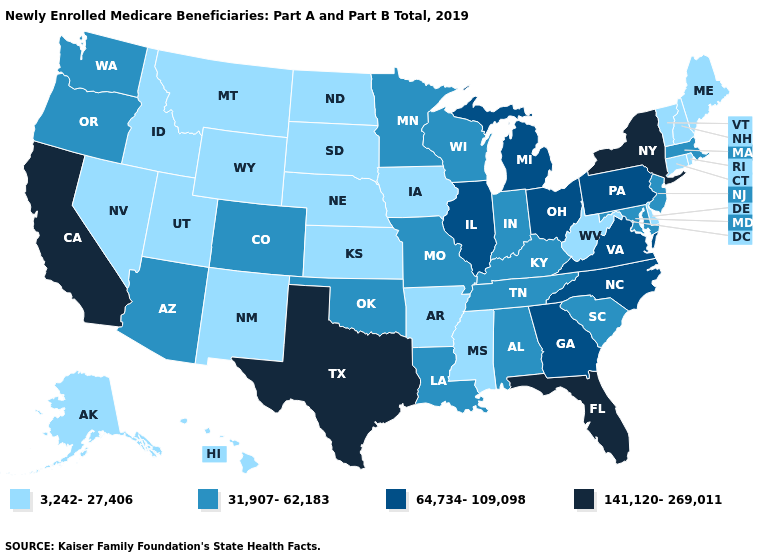What is the value of Wisconsin?
Answer briefly. 31,907-62,183. Which states have the lowest value in the Northeast?
Concise answer only. Connecticut, Maine, New Hampshire, Rhode Island, Vermont. Does Georgia have the lowest value in the USA?
Quick response, please. No. Name the states that have a value in the range 31,907-62,183?
Concise answer only. Alabama, Arizona, Colorado, Indiana, Kentucky, Louisiana, Maryland, Massachusetts, Minnesota, Missouri, New Jersey, Oklahoma, Oregon, South Carolina, Tennessee, Washington, Wisconsin. Among the states that border Virginia , which have the lowest value?
Keep it brief. West Virginia. What is the value of Colorado?
Give a very brief answer. 31,907-62,183. Does Louisiana have a higher value than Utah?
Keep it brief. Yes. What is the value of South Dakota?
Short answer required. 3,242-27,406. Does the first symbol in the legend represent the smallest category?
Be succinct. Yes. What is the value of Hawaii?
Keep it brief. 3,242-27,406. Among the states that border Mississippi , does Arkansas have the lowest value?
Be succinct. Yes. Name the states that have a value in the range 3,242-27,406?
Short answer required. Alaska, Arkansas, Connecticut, Delaware, Hawaii, Idaho, Iowa, Kansas, Maine, Mississippi, Montana, Nebraska, Nevada, New Hampshire, New Mexico, North Dakota, Rhode Island, South Dakota, Utah, Vermont, West Virginia, Wyoming. Does the map have missing data?
Give a very brief answer. No. What is the value of Indiana?
Be succinct. 31,907-62,183. Among the states that border New Hampshire , which have the lowest value?
Answer briefly. Maine, Vermont. 